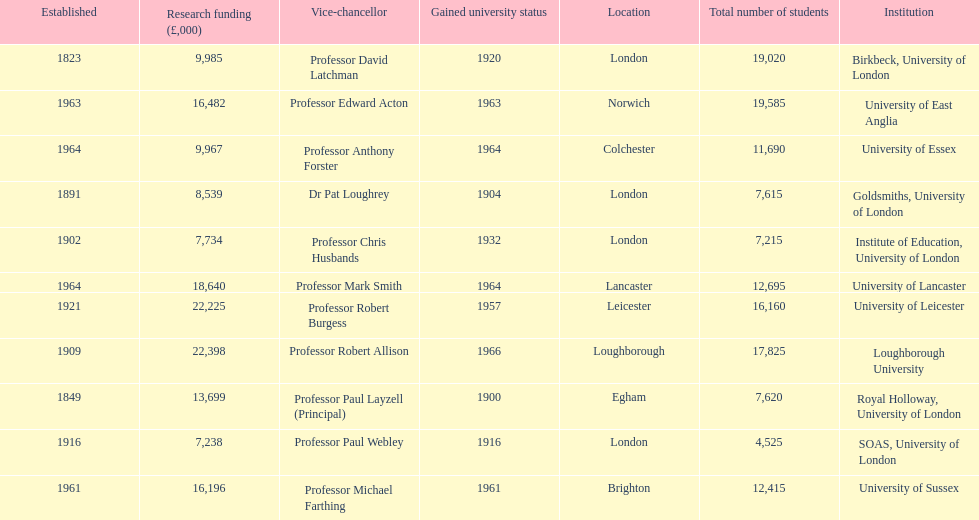Would you mind parsing the complete table? {'header': ['Established', 'Research funding (£,000)', 'Vice-chancellor', 'Gained university status', 'Location', 'Total number of students', 'Institution'], 'rows': [['1823', '9,985', 'Professor David Latchman', '1920', 'London', '19,020', 'Birkbeck, University of London'], ['1963', '16,482', 'Professor Edward Acton', '1963', 'Norwich', '19,585', 'University of East Anglia'], ['1964', '9,967', 'Professor Anthony Forster', '1964', 'Colchester', '11,690', 'University of Essex'], ['1891', '8,539', 'Dr Pat Loughrey', '1904', 'London', '7,615', 'Goldsmiths, University of London'], ['1902', '7,734', 'Professor Chris Husbands', '1932', 'London', '7,215', 'Institute of Education, University of London'], ['1964', '18,640', 'Professor Mark Smith', '1964', 'Lancaster', '12,695', 'University of Lancaster'], ['1921', '22,225', 'Professor Robert Burgess', '1957', 'Leicester', '16,160', 'University of Leicester'], ['1909', '22,398', 'Professor Robert Allison', '1966', 'Loughborough', '17,825', 'Loughborough University'], ['1849', '13,699', 'Professor Paul Layzell (Principal)', '1900', 'Egham', '7,620', 'Royal Holloway, University of London'], ['1916', '7,238', 'Professor Paul Webley', '1916', 'London', '4,525', 'SOAS, University of London'], ['1961', '16,196', 'Professor Michael Farthing', '1961', 'Brighton', '12,415', 'University of Sussex']]} How many of the institutions are located in london? 4. 